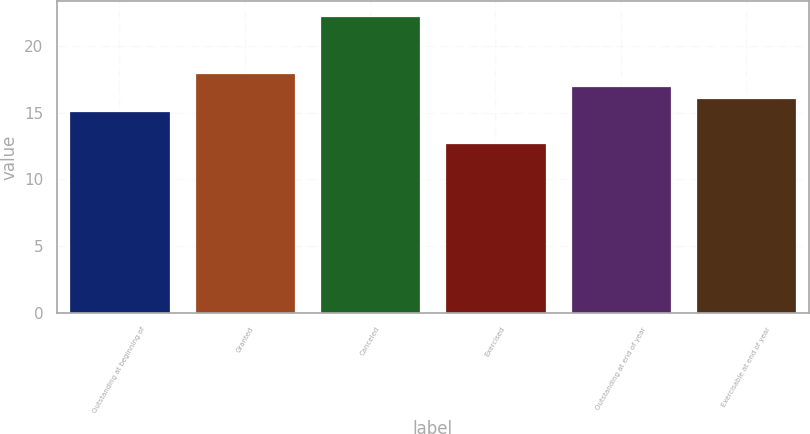Convert chart to OTSL. <chart><loc_0><loc_0><loc_500><loc_500><bar_chart><fcel>Outstanding at beginning of<fcel>Granted<fcel>Canceled<fcel>Exercised<fcel>Outstanding at end of year<fcel>Exercisable at end of year<nl><fcel>15.14<fcel>17.99<fcel>22.28<fcel>12.77<fcel>17.04<fcel>16.09<nl></chart> 